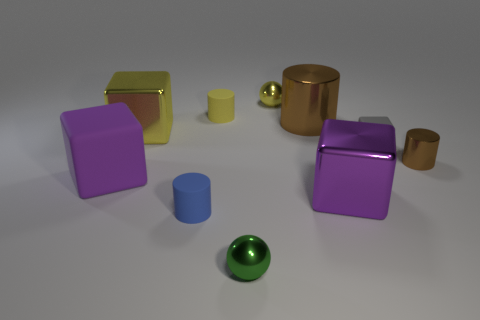Subtract 1 cylinders. How many cylinders are left? 3 Subtract all red cylinders. Subtract all red balls. How many cylinders are left? 4 Subtract all blocks. How many objects are left? 6 Add 7 gray blocks. How many gray blocks exist? 8 Subtract 1 yellow balls. How many objects are left? 9 Subtract all gray blocks. Subtract all small blue metallic cubes. How many objects are left? 9 Add 3 small yellow objects. How many small yellow objects are left? 5 